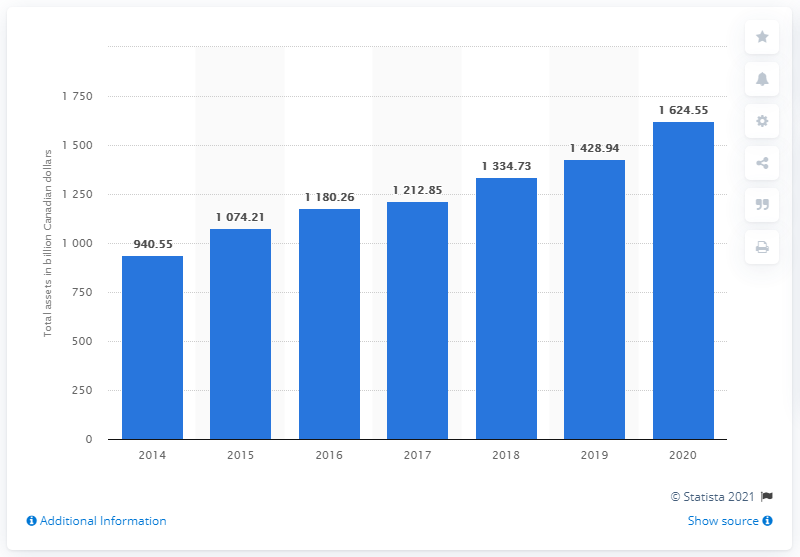Mention a couple of crucial points in this snapshot. In 2020, RBC's assets in Canadian dollars were valued at CAD 1,624.55. RBC's assets in 2014 were valued at 940.55. 